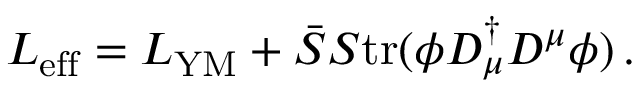Convert formula to latex. <formula><loc_0><loc_0><loc_500><loc_500>L _ { e f f } = L _ { Y M } + \bar { S } S t r ( \phi D _ { \mu } ^ { \dagger } D ^ { \mu } \phi ) \, .</formula> 